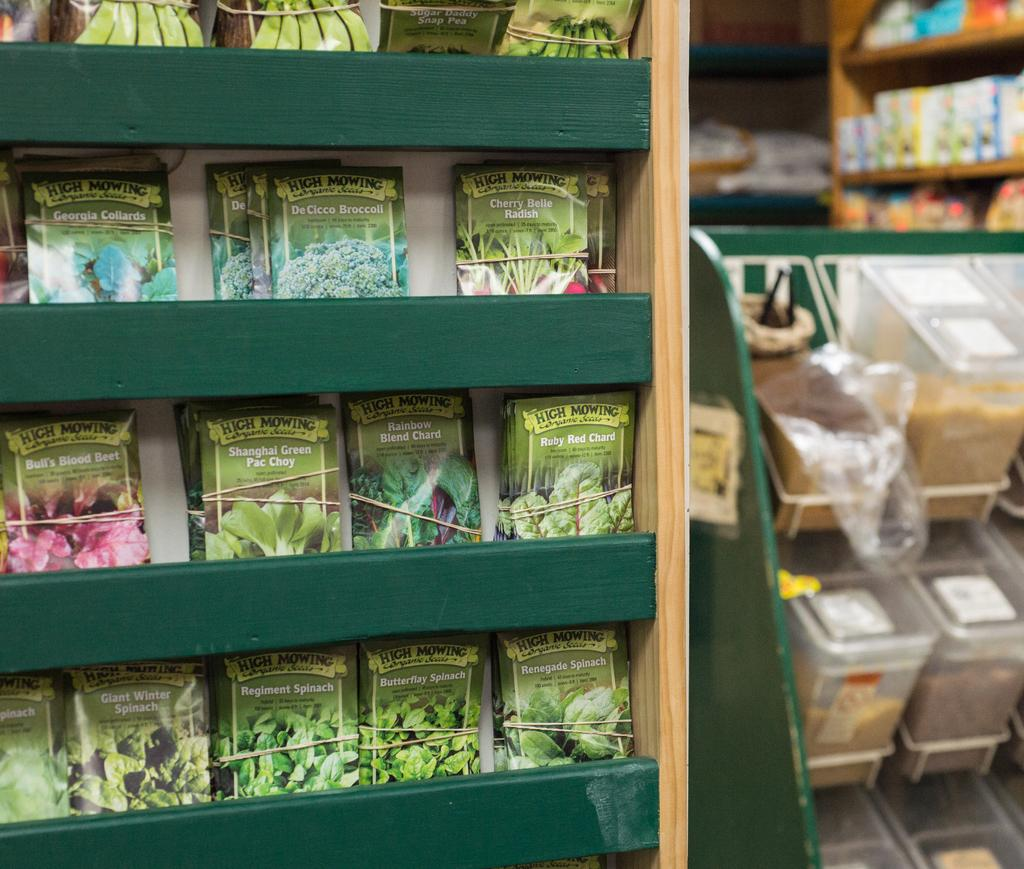<image>
Create a compact narrative representing the image presented. A pack of High Mowing seeds are lined up in a grocery store isle. 